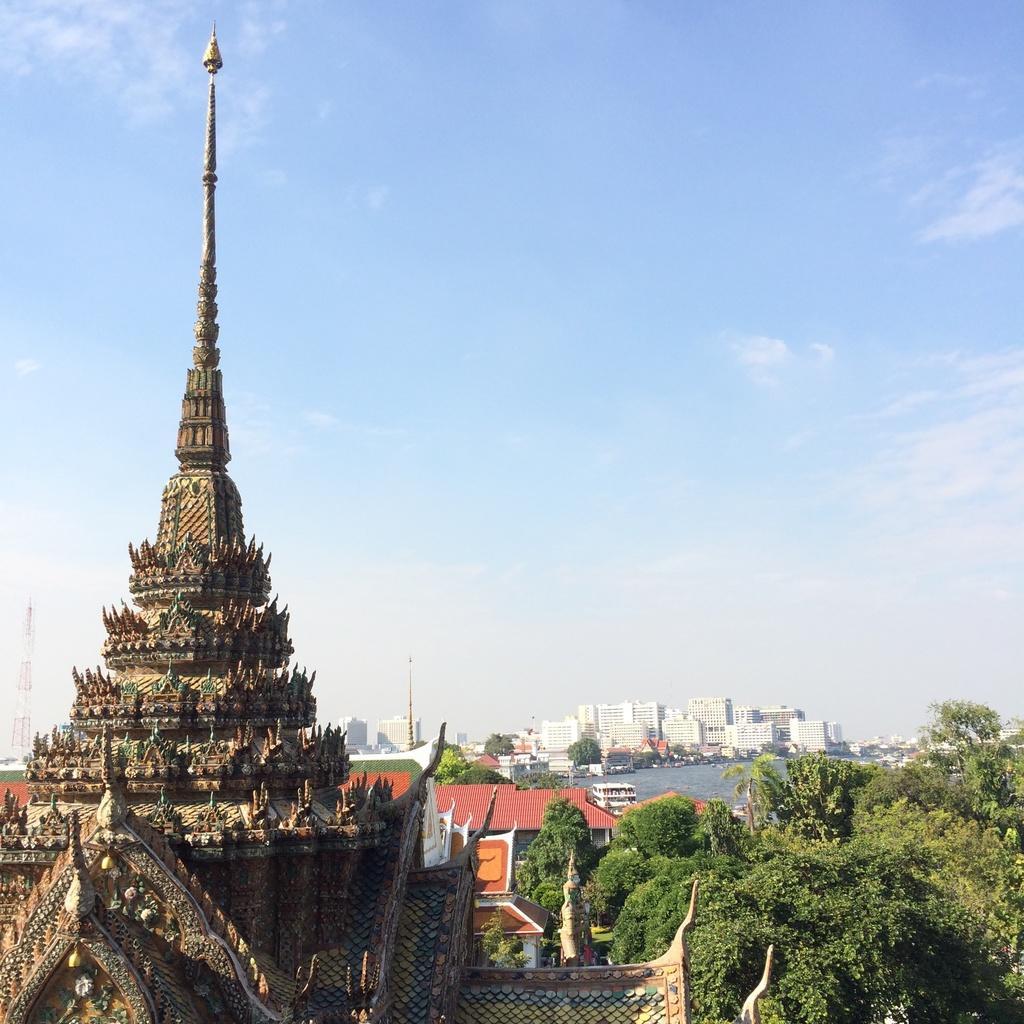In one or two sentences, can you explain what this image depicts? In this image there are buildings. There are trees. There is water. There are towers in the background. There are clouds in the sky. 